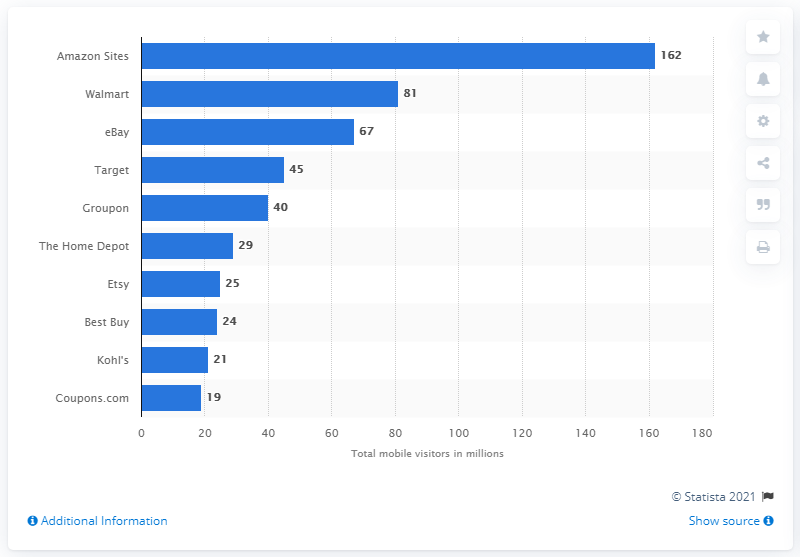Draw attention to some important aspects in this diagram. In September 2018, the number of mobile visitors who visited Amazon sites was 162 million. 